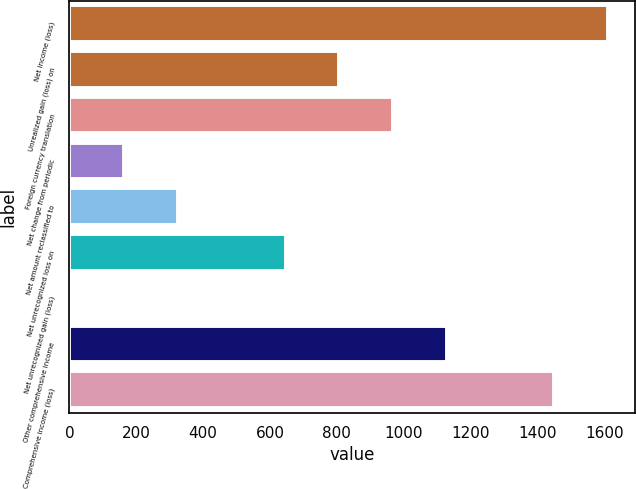Convert chart. <chart><loc_0><loc_0><loc_500><loc_500><bar_chart><fcel>Net income (loss)<fcel>Unrealized gain (loss) on<fcel>Foreign currency translation<fcel>Net change from periodic<fcel>Net amount reclassified to<fcel>Net unrecognized loss on<fcel>Net unrecognized gain (loss)<fcel>Other comprehensive income<fcel>Comprehensive income (loss)<nl><fcel>1611<fcel>807.5<fcel>968.2<fcel>164.7<fcel>325.4<fcel>646.8<fcel>4<fcel>1128.9<fcel>1450.3<nl></chart> 